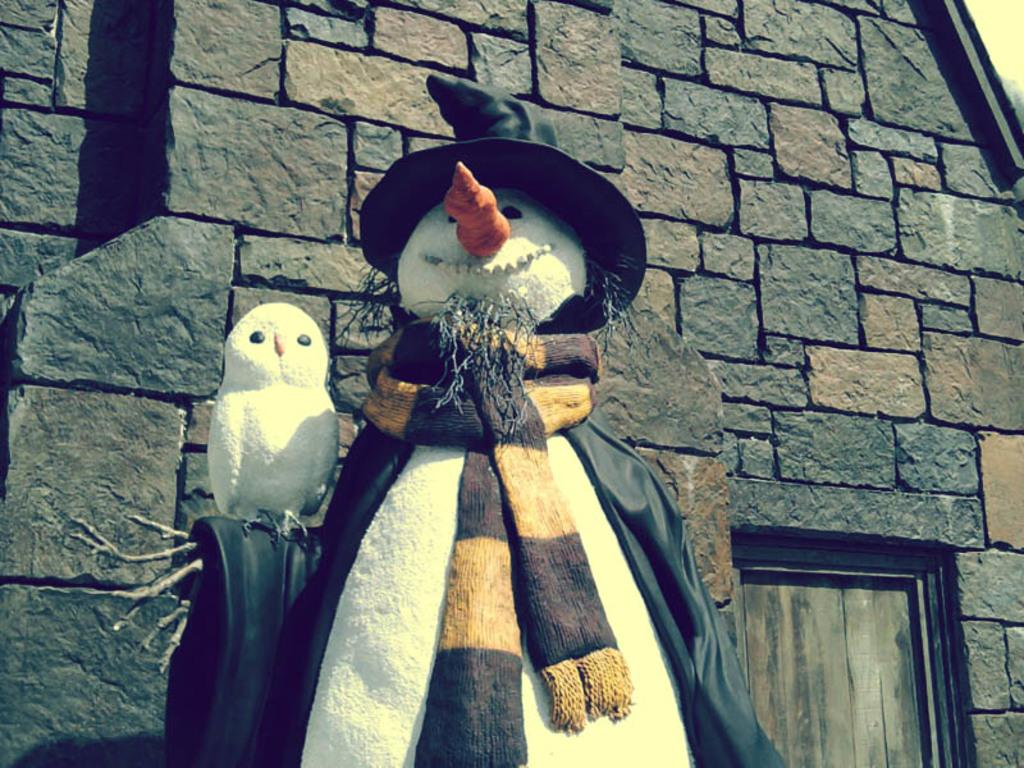What is the main subject in the image? There is a snowman in the image. Are there any other winter-themed creatures present? Yes, there is a snowbird in the image. What accessories are visible on the snowman? A scarf, a coat, and a hat are present in the image. What is the background of the image? There is a house and a door behind the snowman. What else can be seen in the image? There are branches visible. How many boys are working on the snowman's nerves in the image? There are no boys, work, or nerves present in the image. 